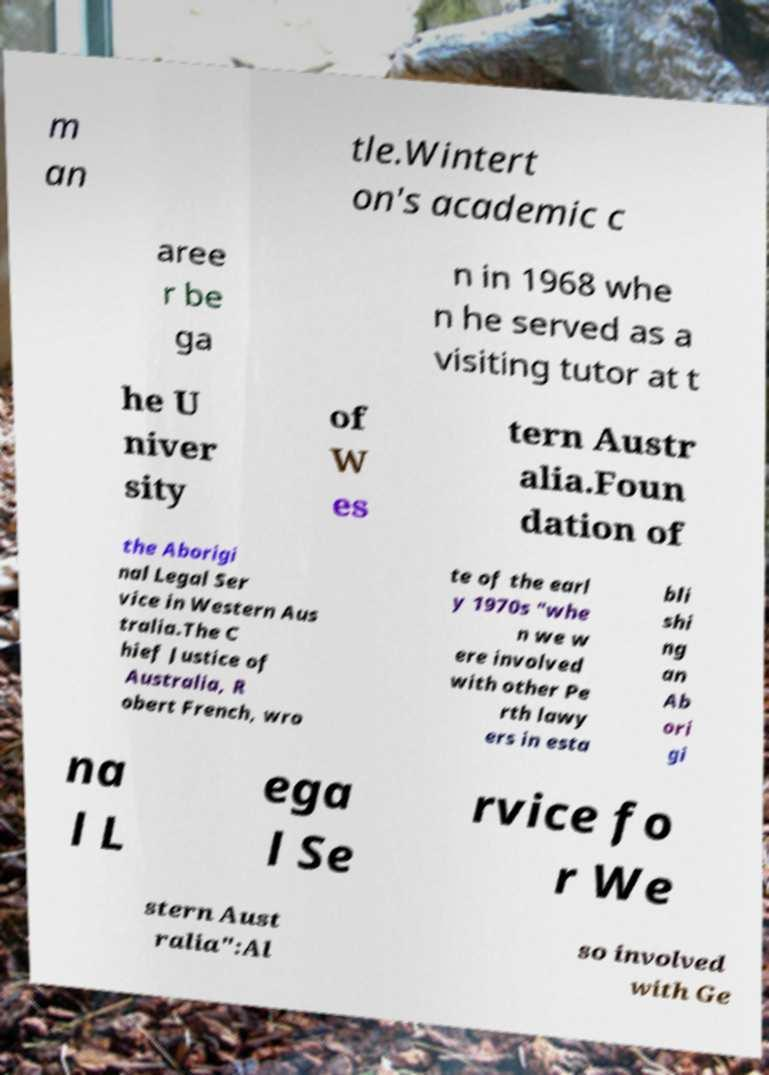I need the written content from this picture converted into text. Can you do that? m an tle.Wintert on's academic c aree r be ga n in 1968 whe n he served as a visiting tutor at t he U niver sity of W es tern Austr alia.Foun dation of the Aborigi nal Legal Ser vice in Western Aus tralia.The C hief Justice of Australia, R obert French, wro te of the earl y 1970s "whe n we w ere involved with other Pe rth lawy ers in esta bli shi ng an Ab ori gi na l L ega l Se rvice fo r We stern Aust ralia":Al so involved with Ge 